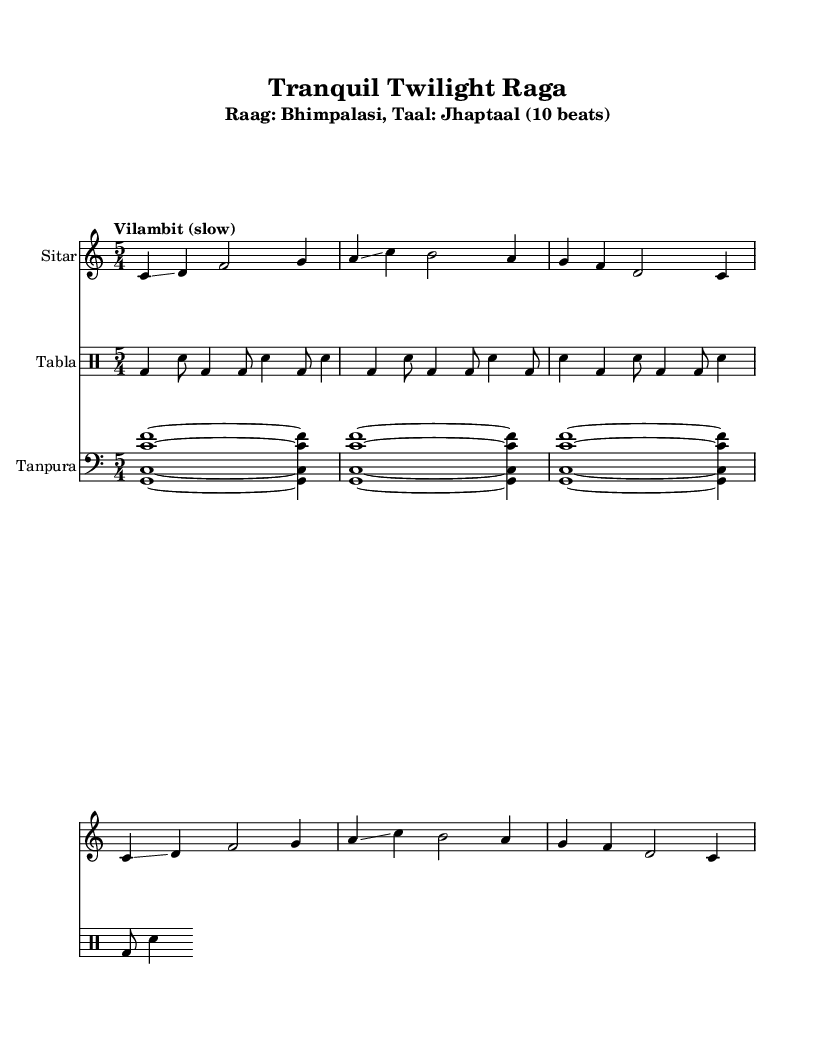What is the title of this piece? The title is found at the top of the sheet music and states the name of the composition.
Answer: Tranquil Twilight Raga What is the time signature of this music? The time signature is indicated next to the key signature, showing how many beats are in each measure. Here, it shows 5 beats in a measure.
Answer: 5/4 What is the tempo marking of this music? The tempo marking specifies the speed of the piece and is usually presented above the staff. It indicates a slow pace for the music.
Answer: Vilambit (slow) What are the instruments used in this score? The instruments are listed under their respective staffs at the beginning of the score. Each staff corresponds to a different instrument.
Answer: Sitar, Tabla, Tanpura How many measures are in the main melody section? By counting the measures in the main melody section, one can determine the total number of measures played in the piece. The excerpt contains five measures.
Answer: Five What is the main raga of this piece? The main raga is specified in the subtitle. It often indicates the mode or scale that shapes the composition.
Answer: Bhimpalasi Is there a repeated section in the music? By analyzing the score, one can see that certain phrases of the music are repeated. This is common in classical compositions for emphasis.
Answer: Yes 